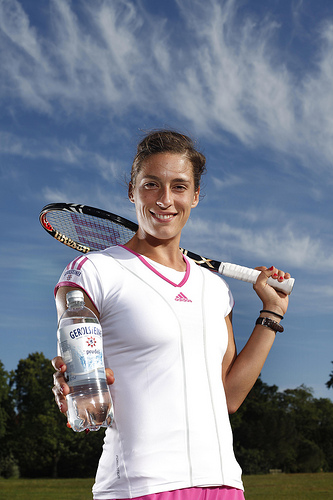What sport does the person in the image appear to be associated with? The individual in the image appears to be associated with tennis, as indicated by her attire and the tennis racket she's holding.  What can you tell about the weather in the image? The weather appears to be fair and sunny, with a few clouds scattered across the blue sky, suggesting it's a good day for outdoor activities such as tennis. 